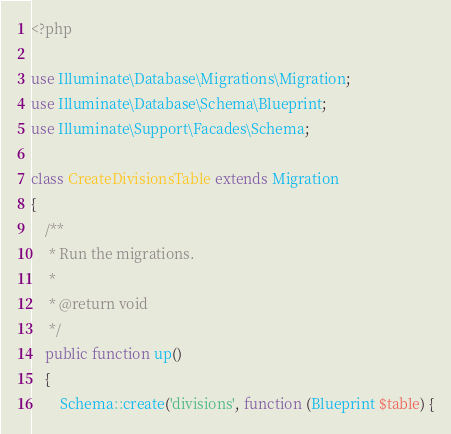<code> <loc_0><loc_0><loc_500><loc_500><_PHP_><?php

use Illuminate\Database\Migrations\Migration;
use Illuminate\Database\Schema\Blueprint;
use Illuminate\Support\Facades\Schema;

class CreateDivisionsTable extends Migration
{
    /**
     * Run the migrations.
     *
     * @return void
     */
    public function up()
    {
        Schema::create('divisions', function (Blueprint $table) {</code> 